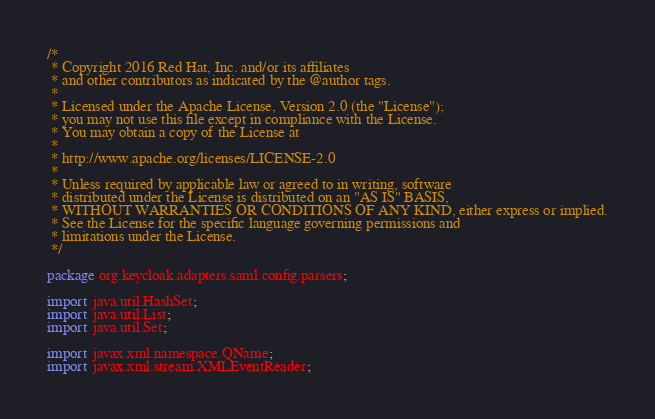<code> <loc_0><loc_0><loc_500><loc_500><_Java_>/*
 * Copyright 2016 Red Hat, Inc. and/or its affiliates
 * and other contributors as indicated by the @author tags.
 *
 * Licensed under the Apache License, Version 2.0 (the "License");
 * you may not use this file except in compliance with the License.
 * You may obtain a copy of the License at
 *
 * http://www.apache.org/licenses/LICENSE-2.0
 *
 * Unless required by applicable law or agreed to in writing, software
 * distributed under the License is distributed on an "AS IS" BASIS,
 * WITHOUT WARRANTIES OR CONDITIONS OF ANY KIND, either express or implied.
 * See the License for the specific language governing permissions and
 * limitations under the License.
 */

package org.keycloak.adapters.saml.config.parsers;

import java.util.HashSet;
import java.util.List;
import java.util.Set;

import javax.xml.namespace.QName;
import javax.xml.stream.XMLEventReader;</code> 